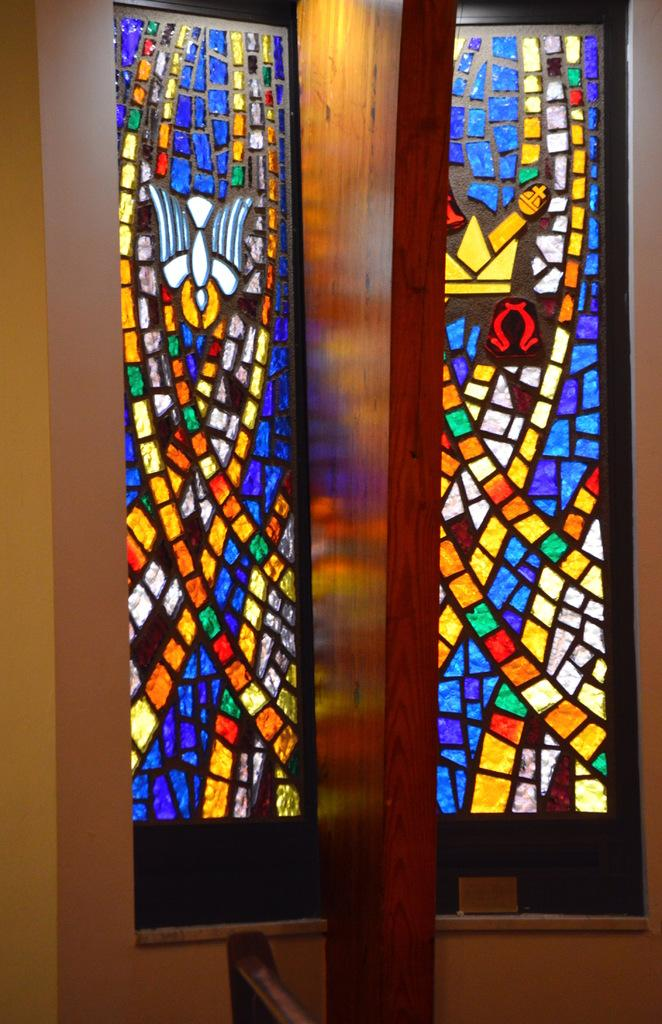What type of windows can be seen in the background of the image? There are stained glass windows in the background of the image. What is located in the front of the image? There is a wall in the front of the image. What separates the stained glass windows in the image? There is a wooden partition in the center of the windows. How many toes can be seen on the wooden partition in the image? There are no toes present in the image, as it features stained glass windows, a wall, and a wooden partition. What type of development is taking place in the image? There is no development taking place in the image; it is a static scene featuring stained glass windows, a wall, and a wooden partition. 